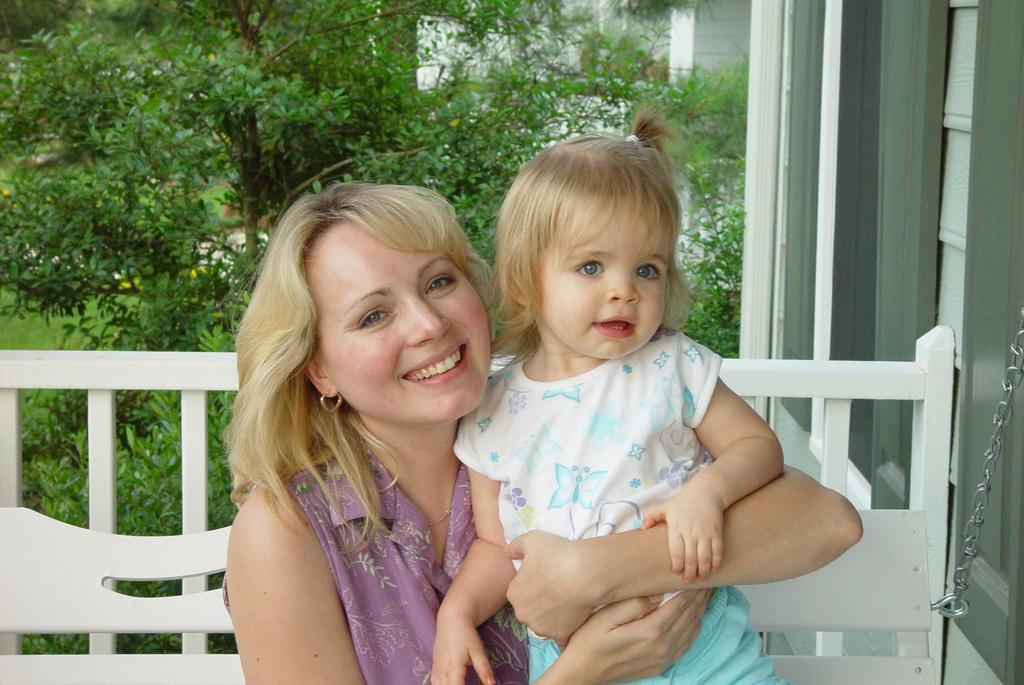Who are the people in the image? There is a lady and a girl in the image. What are they doing in the image? Both the lady and the girl are sitting on a bench. What can be seen in the background of the image? There are trees in the background of the image. What is on the right side of the image? There is a wall on the right side of the image. What type of plastic is covering the stage in the image? There is no stage or plastic present in the image. 